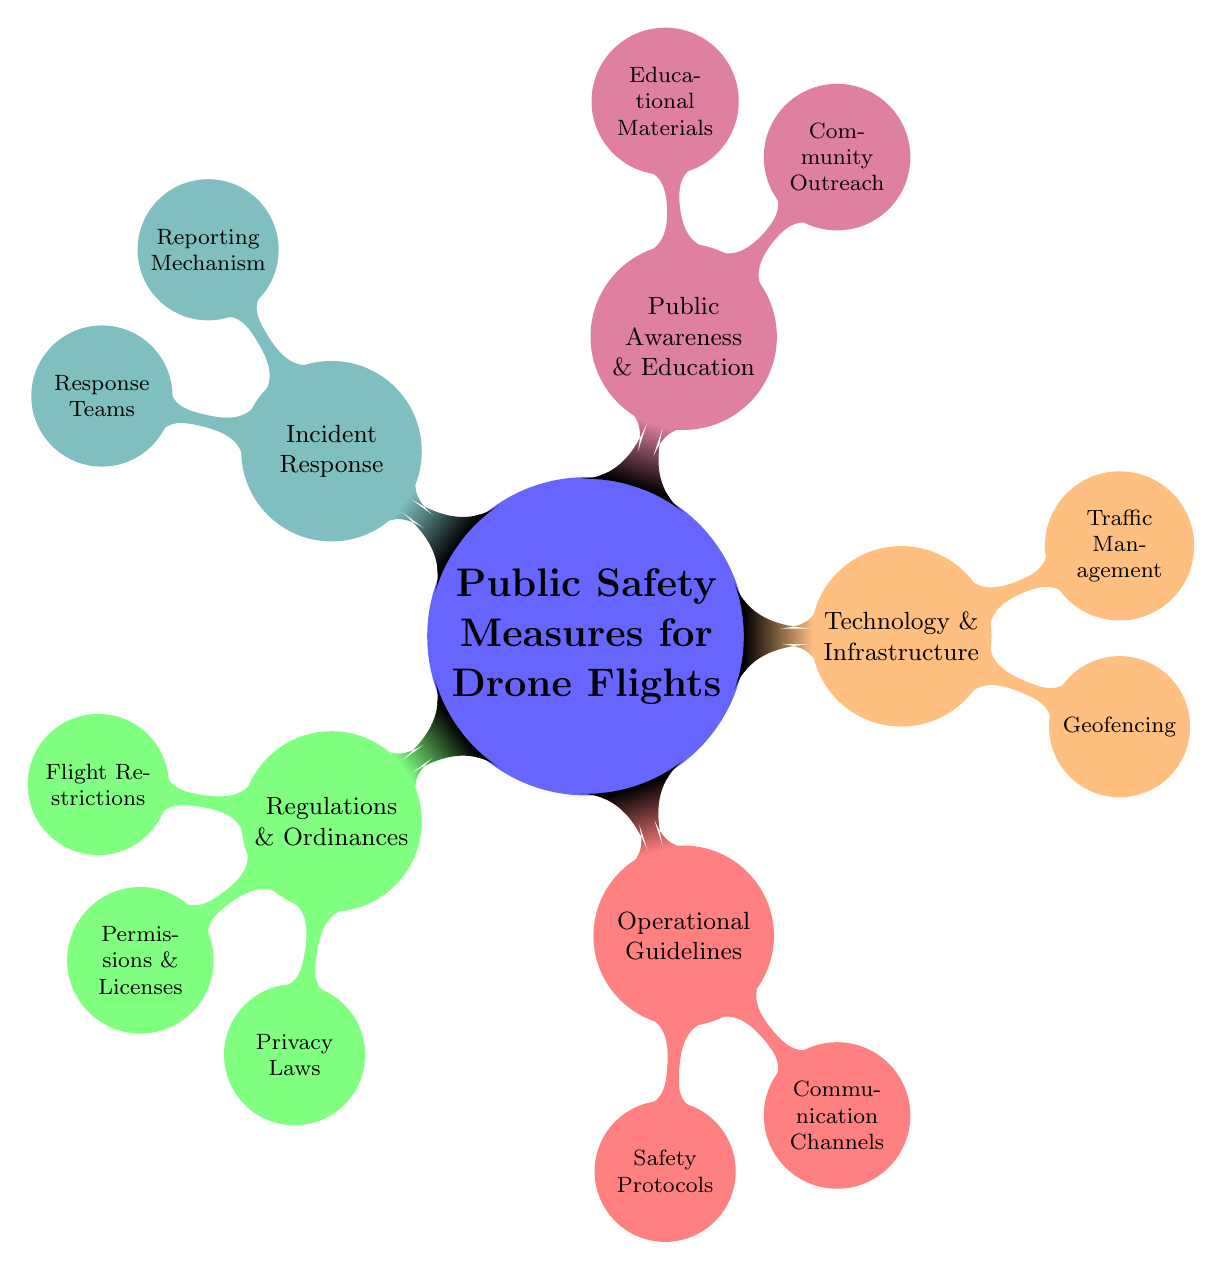What are the main categories of public safety measures? The mind map outlines five main categories: Regulations & Ordinances, Operational Guidelines, Technology & Infrastructure, Public Awareness & Education, and Incident Response. These are the primary nodes branching from the central concept.
Answer: Five How many child nodes are under Technology & Infrastructure? There are two child nodes directly under Technology & Infrastructure: Geofencing and Traffic Management. Count the number of edges leading from this parent node.
Answer: Two What is one example of a flight restriction? Under the Flight Restrictions node, one example listed is No-fly Zones. It directly mentions the various restrictions that apply to drone flights.
Answer: No-fly Zones Which category includes capabilities for communication with local authorities? The category Operational Guidelines includes the node Communication Channels, which refers to coordinating and alerting local authorities during drone operations.
Answer: Operational Guidelines What are the two types of reporting mechanisms listed? The Incident Response node notes two types of reporting mechanisms: a 24/7 Hotline and Online Incident Reports. Both contribute to creating an effective incident response system.
Answer: 24/7 Hotline and Online Incident Reports What is the role of Geofencing as a technological measure? Geofencing refers to Automated Flight Restrictions and Updates via GPS, allowing for real-time management of drone flight paths in designated areas.
Answer: Automated Flight Restrictions and Updates via GPS How does public awareness relate to community outreach? The Public Awareness & Education category includes the Community Outreach node, which emphasizes the importance of engaging the public through informational sessions and safety workshops to enhance awareness of drone usage.
Answer: Community Outreach What is a safety protocol mentioned under Operational Guidelines? The Operational Guidelines categorize Safety Protocols, highlighting a specific example called the Pre-flight Checklist that pilots should complete before taking off.
Answer: Pre-flight Checklist 